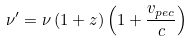Convert formula to latex. <formula><loc_0><loc_0><loc_500><loc_500>\nu ^ { \prime } = \nu \left ( 1 + z \right ) \left ( 1 + \frac { v _ { p e c } } { c } \right )</formula> 